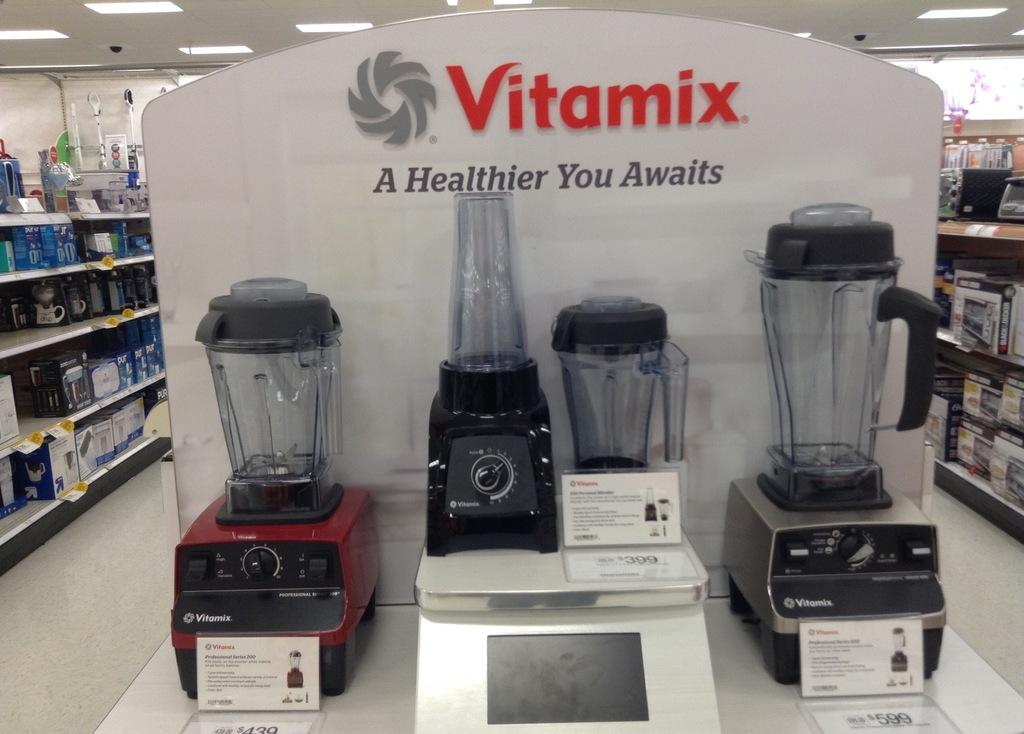<image>
Create a compact narrative representing the image presented. some Vitamix items up for sale on a shelf 